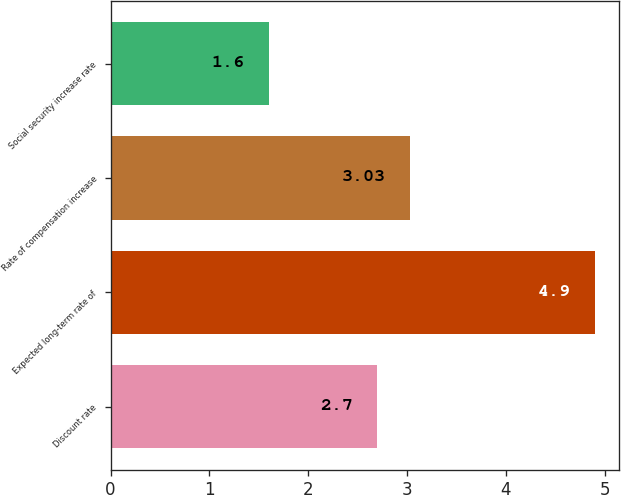Convert chart to OTSL. <chart><loc_0><loc_0><loc_500><loc_500><bar_chart><fcel>Discount rate<fcel>Expected long-term rate of<fcel>Rate of compensation increase<fcel>Social security increase rate<nl><fcel>2.7<fcel>4.9<fcel>3.03<fcel>1.6<nl></chart> 